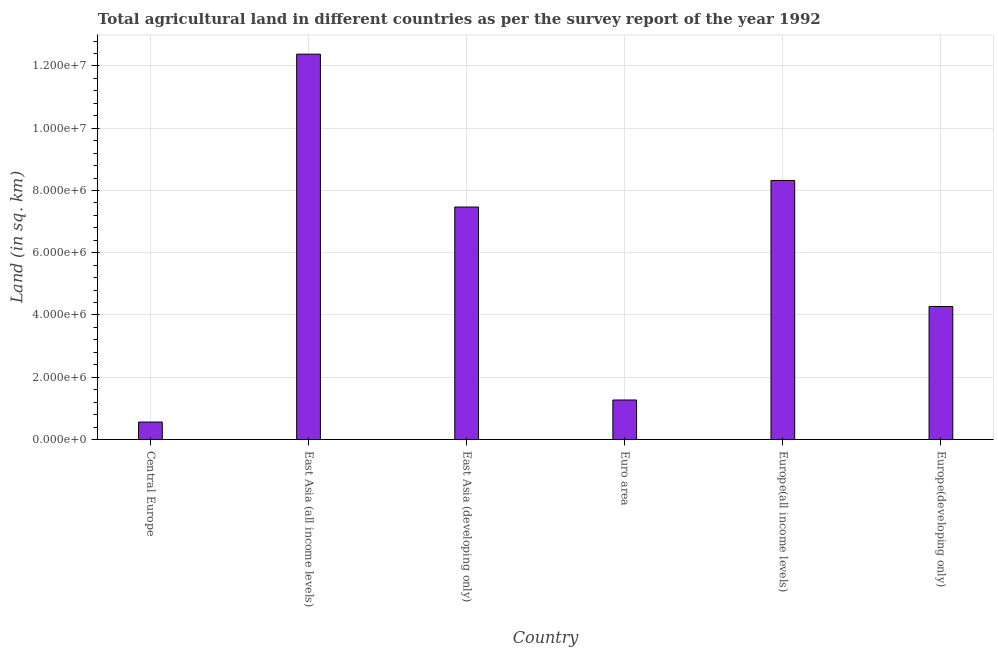Does the graph contain any zero values?
Your response must be concise. No. Does the graph contain grids?
Offer a very short reply. Yes. What is the title of the graph?
Your answer should be very brief. Total agricultural land in different countries as per the survey report of the year 1992. What is the label or title of the Y-axis?
Your answer should be compact. Land (in sq. km). What is the agricultural land in Europe(all income levels)?
Provide a succinct answer. 8.32e+06. Across all countries, what is the maximum agricultural land?
Your answer should be very brief. 1.24e+07. Across all countries, what is the minimum agricultural land?
Keep it short and to the point. 5.61e+05. In which country was the agricultural land maximum?
Your response must be concise. East Asia (all income levels). In which country was the agricultural land minimum?
Your response must be concise. Central Europe. What is the sum of the agricultural land?
Your response must be concise. 3.43e+07. What is the difference between the agricultural land in Central Europe and Europe(developing only)?
Provide a succinct answer. -3.71e+06. What is the average agricultural land per country?
Provide a short and direct response. 5.71e+06. What is the median agricultural land?
Your answer should be very brief. 5.87e+06. What is the ratio of the agricultural land in Euro area to that in Europe(all income levels)?
Your response must be concise. 0.15. What is the difference between the highest and the second highest agricultural land?
Ensure brevity in your answer.  4.06e+06. Is the sum of the agricultural land in Euro area and Europe(developing only) greater than the maximum agricultural land across all countries?
Make the answer very short. No. What is the difference between the highest and the lowest agricultural land?
Ensure brevity in your answer.  1.18e+07. In how many countries, is the agricultural land greater than the average agricultural land taken over all countries?
Offer a terse response. 3. How many bars are there?
Offer a terse response. 6. Are the values on the major ticks of Y-axis written in scientific E-notation?
Your response must be concise. Yes. What is the Land (in sq. km) in Central Europe?
Offer a terse response. 5.61e+05. What is the Land (in sq. km) of East Asia (all income levels)?
Ensure brevity in your answer.  1.24e+07. What is the Land (in sq. km) in East Asia (developing only)?
Offer a very short reply. 7.47e+06. What is the Land (in sq. km) of Euro area?
Your answer should be very brief. 1.27e+06. What is the Land (in sq. km) in Europe(all income levels)?
Make the answer very short. 8.32e+06. What is the Land (in sq. km) of Europe(developing only)?
Give a very brief answer. 4.27e+06. What is the difference between the Land (in sq. km) in Central Europe and East Asia (all income levels)?
Ensure brevity in your answer.  -1.18e+07. What is the difference between the Land (in sq. km) in Central Europe and East Asia (developing only)?
Your answer should be compact. -6.91e+06. What is the difference between the Land (in sq. km) in Central Europe and Euro area?
Make the answer very short. -7.09e+05. What is the difference between the Land (in sq. km) in Central Europe and Europe(all income levels)?
Provide a short and direct response. -7.76e+06. What is the difference between the Land (in sq. km) in Central Europe and Europe(developing only)?
Make the answer very short. -3.71e+06. What is the difference between the Land (in sq. km) in East Asia (all income levels) and East Asia (developing only)?
Provide a short and direct response. 4.91e+06. What is the difference between the Land (in sq. km) in East Asia (all income levels) and Euro area?
Your answer should be compact. 1.11e+07. What is the difference between the Land (in sq. km) in East Asia (all income levels) and Europe(all income levels)?
Give a very brief answer. 4.06e+06. What is the difference between the Land (in sq. km) in East Asia (all income levels) and Europe(developing only)?
Offer a very short reply. 8.11e+06. What is the difference between the Land (in sq. km) in East Asia (developing only) and Euro area?
Offer a very short reply. 6.20e+06. What is the difference between the Land (in sq. km) in East Asia (developing only) and Europe(all income levels)?
Your answer should be very brief. -8.54e+05. What is the difference between the Land (in sq. km) in East Asia (developing only) and Europe(developing only)?
Offer a terse response. 3.19e+06. What is the difference between the Land (in sq. km) in Euro area and Europe(all income levels)?
Offer a terse response. -7.05e+06. What is the difference between the Land (in sq. km) in Euro area and Europe(developing only)?
Provide a succinct answer. -3.00e+06. What is the difference between the Land (in sq. km) in Europe(all income levels) and Europe(developing only)?
Make the answer very short. 4.05e+06. What is the ratio of the Land (in sq. km) in Central Europe to that in East Asia (all income levels)?
Provide a succinct answer. 0.04. What is the ratio of the Land (in sq. km) in Central Europe to that in East Asia (developing only)?
Offer a very short reply. 0.07. What is the ratio of the Land (in sq. km) in Central Europe to that in Euro area?
Offer a terse response. 0.44. What is the ratio of the Land (in sq. km) in Central Europe to that in Europe(all income levels)?
Offer a terse response. 0.07. What is the ratio of the Land (in sq. km) in Central Europe to that in Europe(developing only)?
Give a very brief answer. 0.13. What is the ratio of the Land (in sq. km) in East Asia (all income levels) to that in East Asia (developing only)?
Provide a short and direct response. 1.66. What is the ratio of the Land (in sq. km) in East Asia (all income levels) to that in Euro area?
Keep it short and to the point. 9.75. What is the ratio of the Land (in sq. km) in East Asia (all income levels) to that in Europe(all income levels)?
Provide a succinct answer. 1.49. What is the ratio of the Land (in sq. km) in East Asia (all income levels) to that in Europe(developing only)?
Make the answer very short. 2.9. What is the ratio of the Land (in sq. km) in East Asia (developing only) to that in Euro area?
Make the answer very short. 5.88. What is the ratio of the Land (in sq. km) in East Asia (developing only) to that in Europe(all income levels)?
Make the answer very short. 0.9. What is the ratio of the Land (in sq. km) in East Asia (developing only) to that in Europe(developing only)?
Offer a very short reply. 1.75. What is the ratio of the Land (in sq. km) in Euro area to that in Europe(all income levels)?
Ensure brevity in your answer.  0.15. What is the ratio of the Land (in sq. km) in Euro area to that in Europe(developing only)?
Your answer should be very brief. 0.3. What is the ratio of the Land (in sq. km) in Europe(all income levels) to that in Europe(developing only)?
Your answer should be compact. 1.95. 